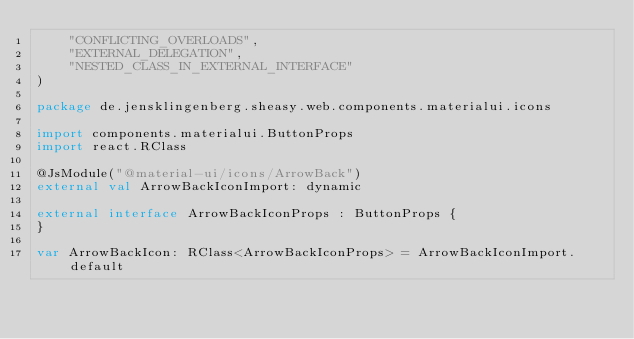<code> <loc_0><loc_0><loc_500><loc_500><_Kotlin_>    "CONFLICTING_OVERLOADS",
    "EXTERNAL_DELEGATION",
    "NESTED_CLASS_IN_EXTERNAL_INTERFACE"
)

package de.jensklingenberg.sheasy.web.components.materialui.icons

import components.materialui.ButtonProps
import react.RClass

@JsModule("@material-ui/icons/ArrowBack")
external val ArrowBackIconImport: dynamic

external interface ArrowBackIconProps : ButtonProps {
}

var ArrowBackIcon: RClass<ArrowBackIconProps> = ArrowBackIconImport.default
</code> 